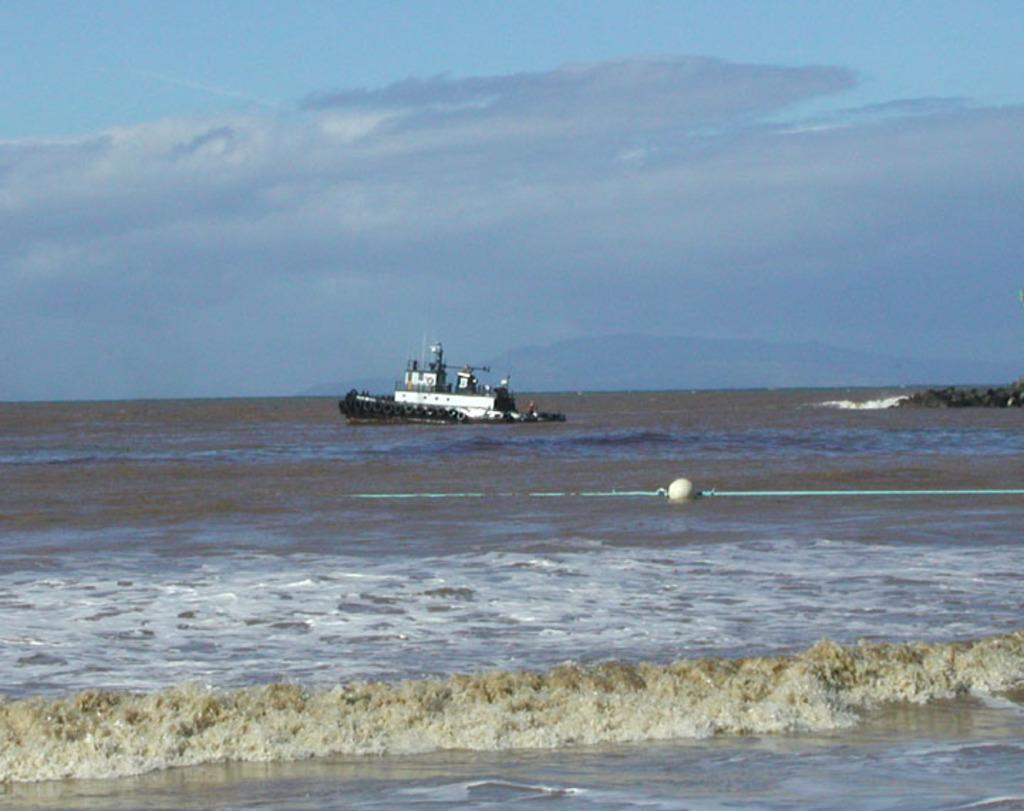What is the main subject of the image? The main subject of the image is a ship. Where is the ship located? The ship is in the sea. What is visible at the top of the image? The sky is visible at the top of the image. What type of water movement can be seen at the bottom of the image? Waves are present at the bottom of the image. Can you see any sticks or noses in the image? There are no sticks or noses present in the image. Is there a zoo visible in the image? There is no zoo present in the image. 